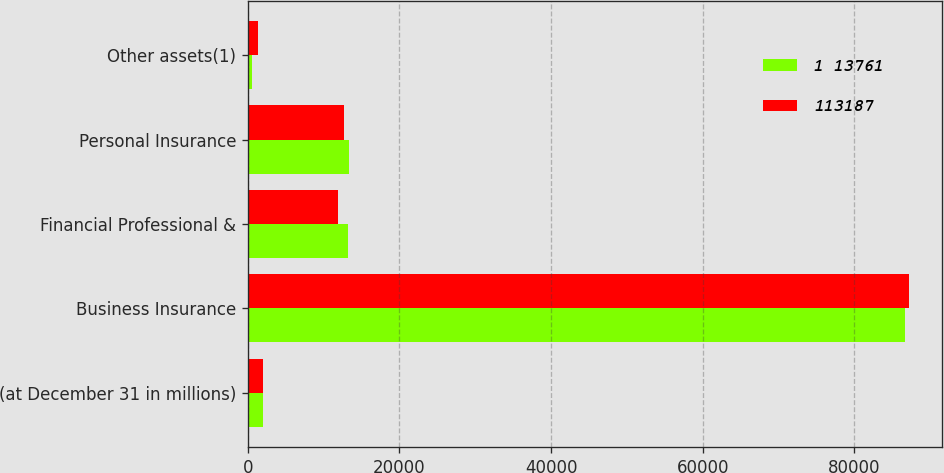Convert chart. <chart><loc_0><loc_0><loc_500><loc_500><stacked_bar_chart><ecel><fcel>(at December 31 in millions)<fcel>Business Insurance<fcel>Financial Professional &<fcel>Personal Insurance<fcel>Other assets(1)<nl><fcel>1 13761<fcel>2006<fcel>86640<fcel>13265<fcel>13294<fcel>562<nl><fcel>113187<fcel>2005<fcel>87188<fcel>11908<fcel>12710<fcel>1381<nl></chart> 